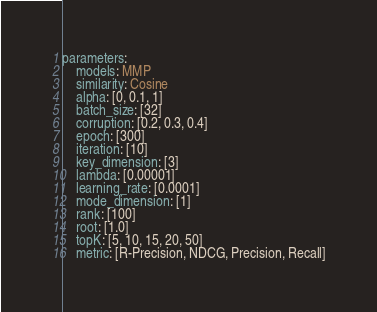Convert code to text. <code><loc_0><loc_0><loc_500><loc_500><_YAML_>parameters:
    models: MMP
    similarity: Cosine
    alpha: [0, 0.1, 1]
    batch_size: [32]
    corruption: [0.2, 0.3, 0.4]
    epoch: [300]
    iteration: [10]
    key_dimension: [3]
    lambda: [0.00001]
    learning_rate: [0.0001]
    mode_dimension: [1]
    rank: [100]
    root: [1.0]
    topK: [5, 10, 15, 20, 50]
    metric: [R-Precision, NDCG, Precision, Recall]</code> 